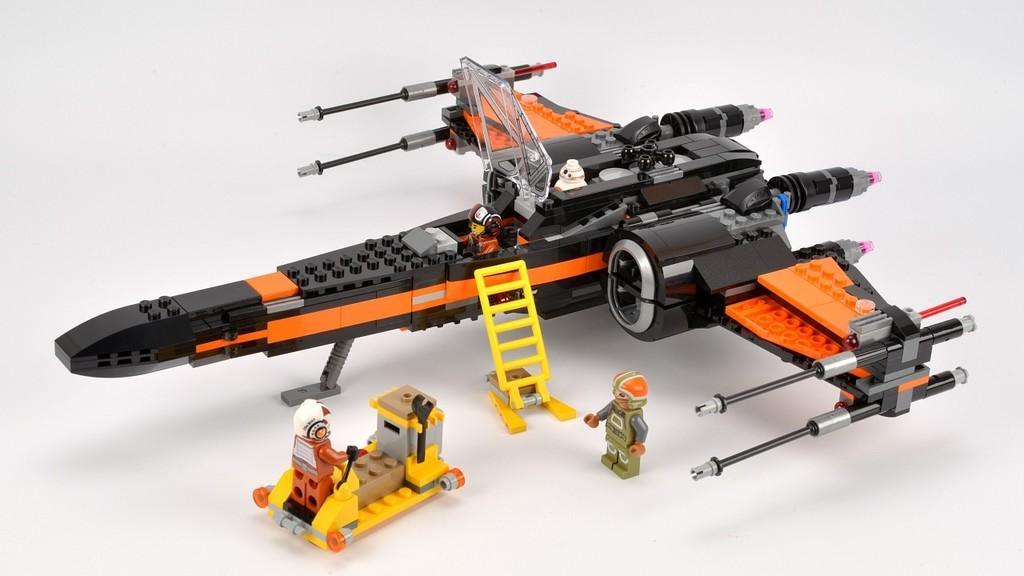Describe this image in one or two sentences. In this picture toys are there. 